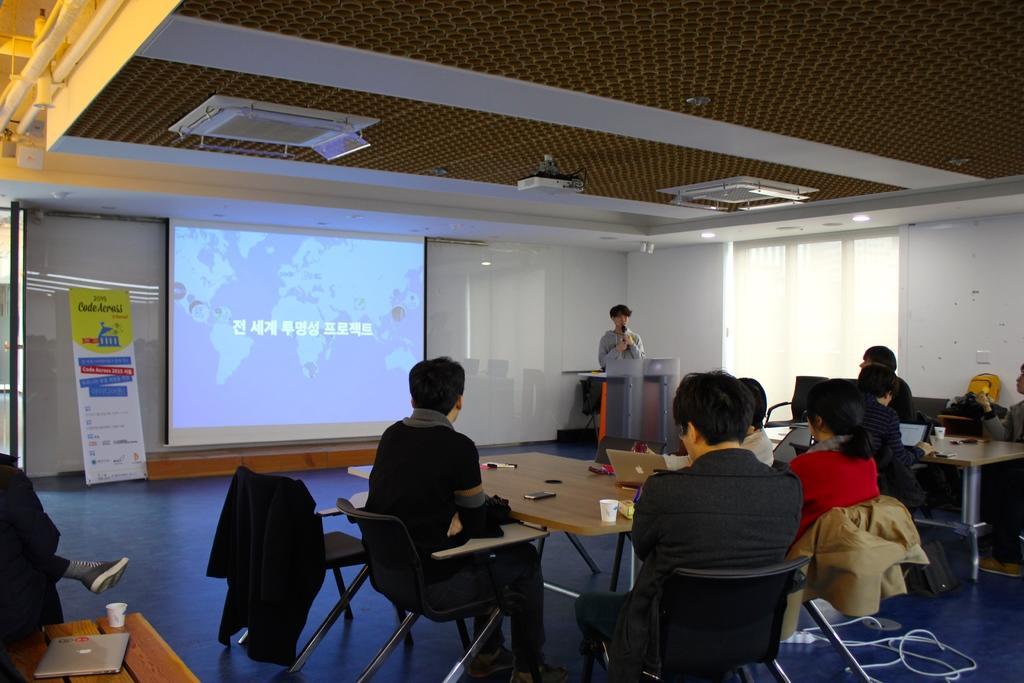Describe this image in one or two sentences. This is a picture taken in a seminar hall, there are a group of people sitting on a chair in front of the people there is a table on the table there is a pen, glass and laptop and there is a man standing behind the podium the man is holding the microphone. Background of this people there is a projector screen, banner and a wall which is in white color. On top of them there is a roof with a projector. 